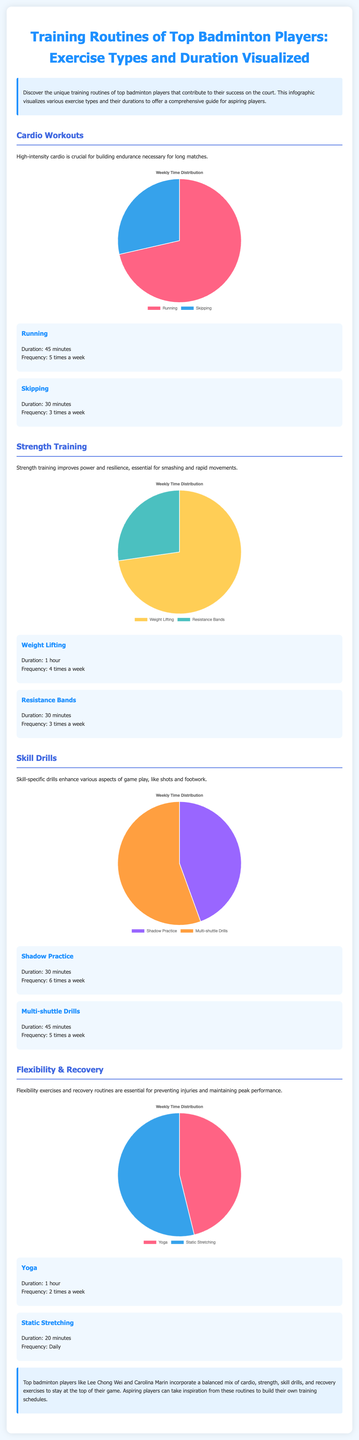What is the duration of running workouts? The document states that running has a duration of 45 minutes.
Answer: 45 minutes How many times a week do top players perform shadow practice? The document indicates that shadow practice is done 6 times a week.
Answer: 6 times What exercise is performed for 1 hour? According to the document, weight lifting and yoga are both listed with a duration of 1 hour.
Answer: Weight lifting, Yoga What is the total duration of multi-shuttle drills? The document specifies that multi-shuttle drills last for 45 minutes.
Answer: 45 minutes What exercise type has a frequency of 2 times a week? The document indicates that yoga is performed 2 times a week.
Answer: Yoga Which exercise has the least duration mentioned? The document states that static stretching has a duration of 20 minutes, which is the least compared to others listed.
Answer: 20 minutes Which category includes resistance bands? The document categorizes resistance bands under strength training.
Answer: Strength training What is the total weekly time for skipping workouts? The document shows that skipping is performed for 30 minutes, 3 times a week, totaling 90 minutes.
Answer: 90 minutes Which chart represents skill drills? The document displays a chart for skill drills titled 'Skill Drills'.
Answer: Skill Drills 